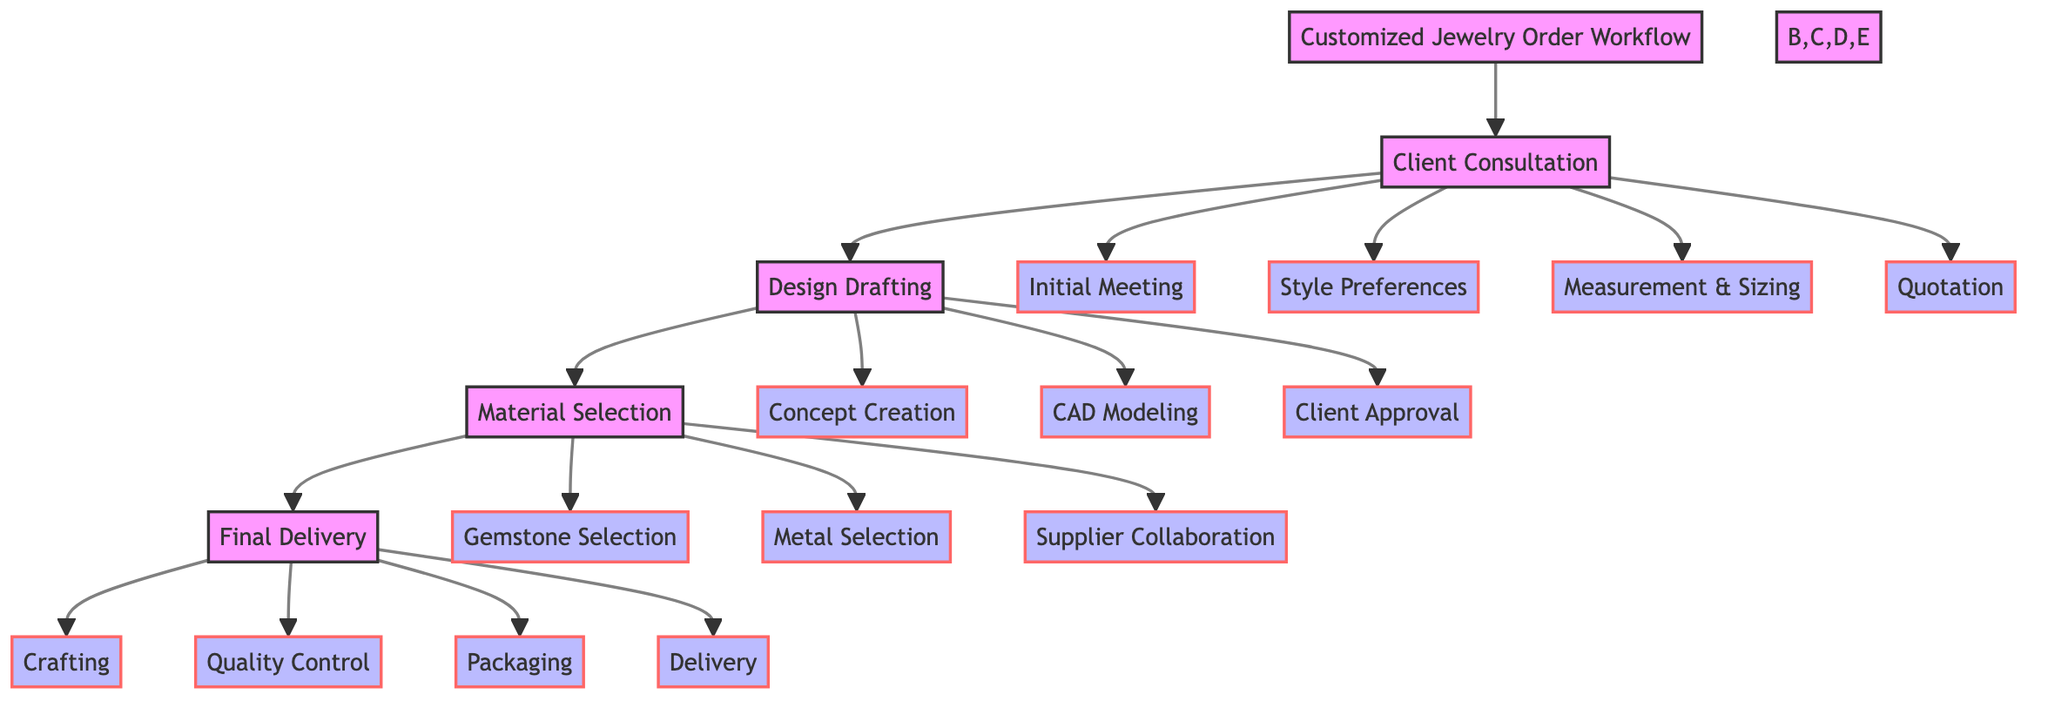What is the first stage in the Customized Jewelry Order Workflow? The diagram indicates that the first stage is "Client Consultation," as it is directly connected to the main workflow node.
Answer: Client Consultation How many main stages are there in the workflow? The flowchart shows four main stages: Client Consultation, Design Drafting, Material Selection, and Final Delivery. This can be counted as there are four distinct sections linked from the main node.
Answer: 4 What follows after Design Drafting in the workflow? The diagram shows that after the "Design Drafting" stage, the next stage is "Material Selection," as indicated by the directed connection in the flowchart.
Answer: Material Selection Which process includes 'Client Approval'? In the flowchart, 'Client Approval' is part of the "Design Drafting" process, as it is directly indicated under this stage.
Answer: Design Drafting What is the last step in the final delivery process? The last step in the "Final Delivery" segment of the flowchart is 'Delivery,' which is represented as the fourth process connected to the "Final Delivery" main node.
Answer: Delivery If a client chooses a gemstone, which stage does this process occur in? The process of choosing a gemstone happens during the "Material Selection" stage, as indicated by the connection from the main workflow node to the respective step.
Answer: Material Selection How many processes are there under the Client Consultation stage? There are four processes listed under "Client Consultation," which can be counted directly from the diagram where each process is outlined beneath this stage.
Answer: 4 What is the relationship between 'Quotation' and 'Initial Meeting'? The relationship is that 'Quotation' is one of the outcomes of the "Client Consultation" stage, following the "Initial Meeting," which outlines the sequence in this segment of the workflow.
Answer: Sequential Which process occurs before 'Quality Control'? The process that occurs before 'Quality Control' is 'Crafting,' as the flowchart shows a direct progression from crafting to quality control in the "Final Delivery" stage.
Answer: Crafting 